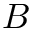<formula> <loc_0><loc_0><loc_500><loc_500>B</formula> 